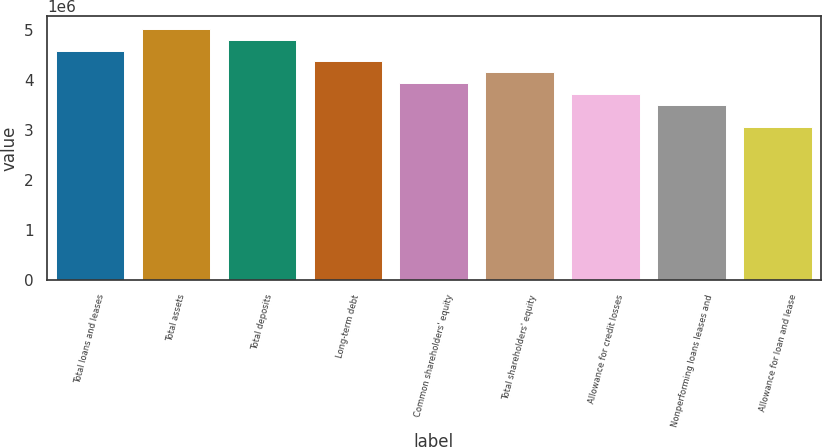Convert chart to OTSL. <chart><loc_0><loc_0><loc_500><loc_500><bar_chart><fcel>Total loans and leases<fcel>Total assets<fcel>Total deposits<fcel>Long-term debt<fcel>Common shareholders' equity<fcel>Total shareholders' equity<fcel>Allowance for credit losses<fcel>Nonperforming loans leases and<fcel>Allowance for loan and lease<nl><fcel>4.58768e+06<fcel>5.0246e+06<fcel>4.80614e+06<fcel>4.36922e+06<fcel>3.9323e+06<fcel>4.15076e+06<fcel>3.71384e+06<fcel>3.49538e+06<fcel>3.05845e+06<nl></chart> 